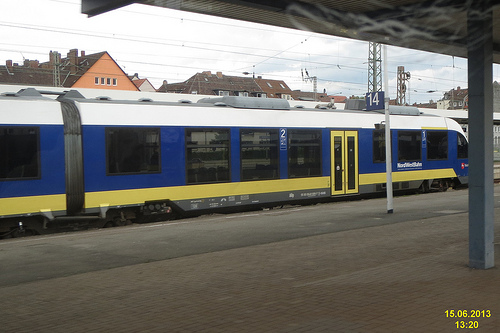Are there both a window and a door in the image? Yes, the train in the image has both windows and doors designed to accommodate passengers boarding and disembarking. 